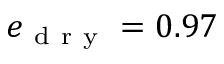Convert formula to latex. <formula><loc_0><loc_0><loc_500><loc_500>e _ { d r y } = 0 . 9 7</formula> 